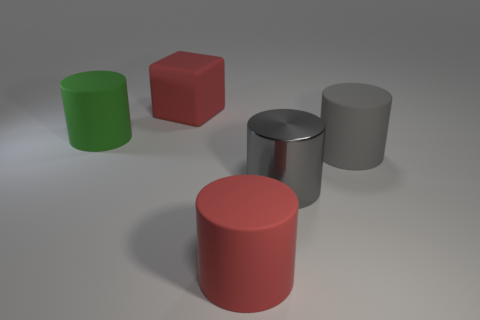There is a large object that is the same color as the large block; what is its material?
Your answer should be very brief. Rubber. Are there fewer gray metallic things that are in front of the gray shiny object than rubber objects that are right of the large rubber block?
Your answer should be very brief. Yes. What number of objects are large purple shiny blocks or red rubber objects that are in front of the big rubber block?
Your response must be concise. 1. What is the material of the other gray object that is the same size as the gray rubber thing?
Your answer should be very brief. Metal. What color is the big matte cylinder that is to the left of the big gray shiny object and right of the large green matte cylinder?
Your answer should be compact. Red. There is a matte cylinder that is in front of the big gray rubber cylinder; is its color the same as the big block?
Ensure brevity in your answer.  Yes. There is a green object that is the same size as the gray metal object; what shape is it?
Give a very brief answer. Cylinder. How many other things are the same color as the big rubber cube?
Offer a very short reply. 1. How many other things are the same material as the green object?
Provide a short and direct response. 3. What is the color of the matte block?
Provide a succinct answer. Red. 